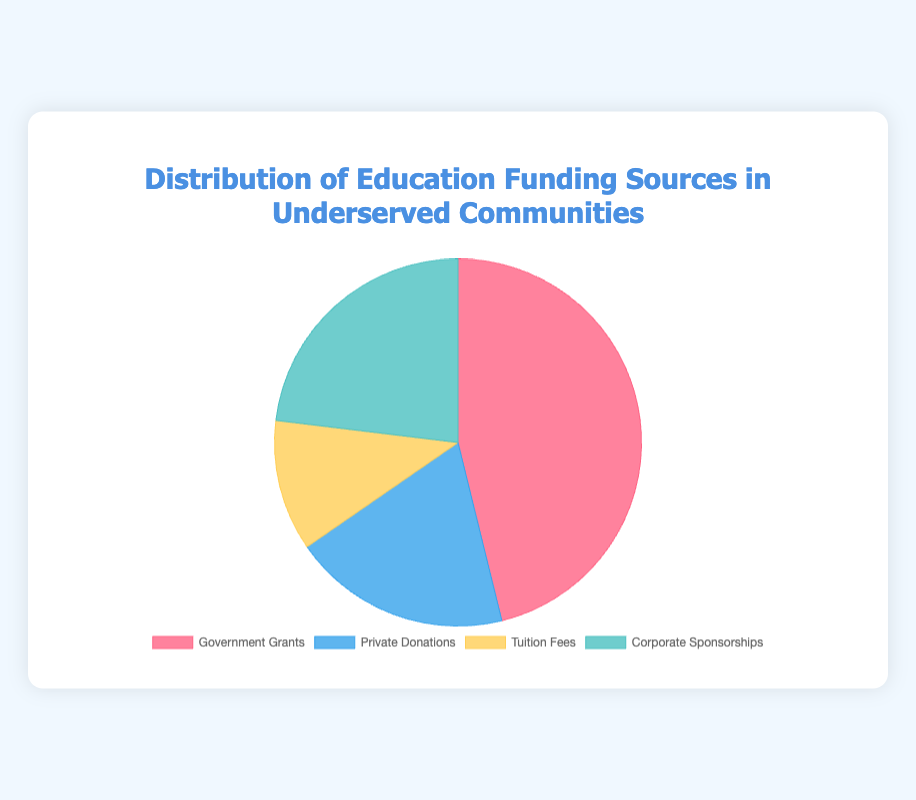Which funding source has the highest percentage? The chart shows that Government Grants cover 60% of the funding sources, making it the highest among the four.
Answer: Government Grants What is the total percentage of the funding sources provided by private entities (Private Donations and Corporate Sponsorships)? Private Donations contribute 25%, and Corporate Sponsorships contribute 30%. Summing these, 25% + 30% = 55%.
Answer: 55% Which segment represents the smallest percentage? The chart indicates that Tuition Fees account for 15%, which is the smallest percentage among the four segments.
Answer: Tuition Fees How does the percentage of Corporate Sponsorships compare to that of Government Grants? Government Grants account for 60%, and Corporate Sponsorships account for 30%. Therefore, Corporate Sponsorships are 30% less than Government Grants.
Answer: Corporate Sponsorships are 30% less By how much percentage do Private Donations exceed Tuition Fees? Private Donations account for 25%, and Tuition Fees account for 15%. The difference is 25% - 15% = 10%.
Answer: 10% What fraction of the total funding does Tuition Fees represent if the total funding is considered 100%? Tuition Fees represent 15%. Therefore, the fraction is 15/100 or 3/20.
Answer: 3/20 If Government Grants were to increase by 10%, what would their new percentage be? The current percentage of Government Grants is 60%. An increase by 10% translates to 60% * 1.1 = 66%.
Answer: 66% What are the colors used to represent each of the funding sources in the chart? Government Grants are represented in red, Private Donations in blue, Tuition Fees in yellow, and Corporate Sponsorships in green.
Answer: Red, Blue, Yellow, Green If the total funding amount is $1 million, how much is contributed by Tuition Fees? Tuition Fees constitute 15%. Hence, the amount contributed by Tuition Fees is 15% of $1 million, i.e., $1,000,000 * 0.15 = $150,000.
Answer: $150,000 